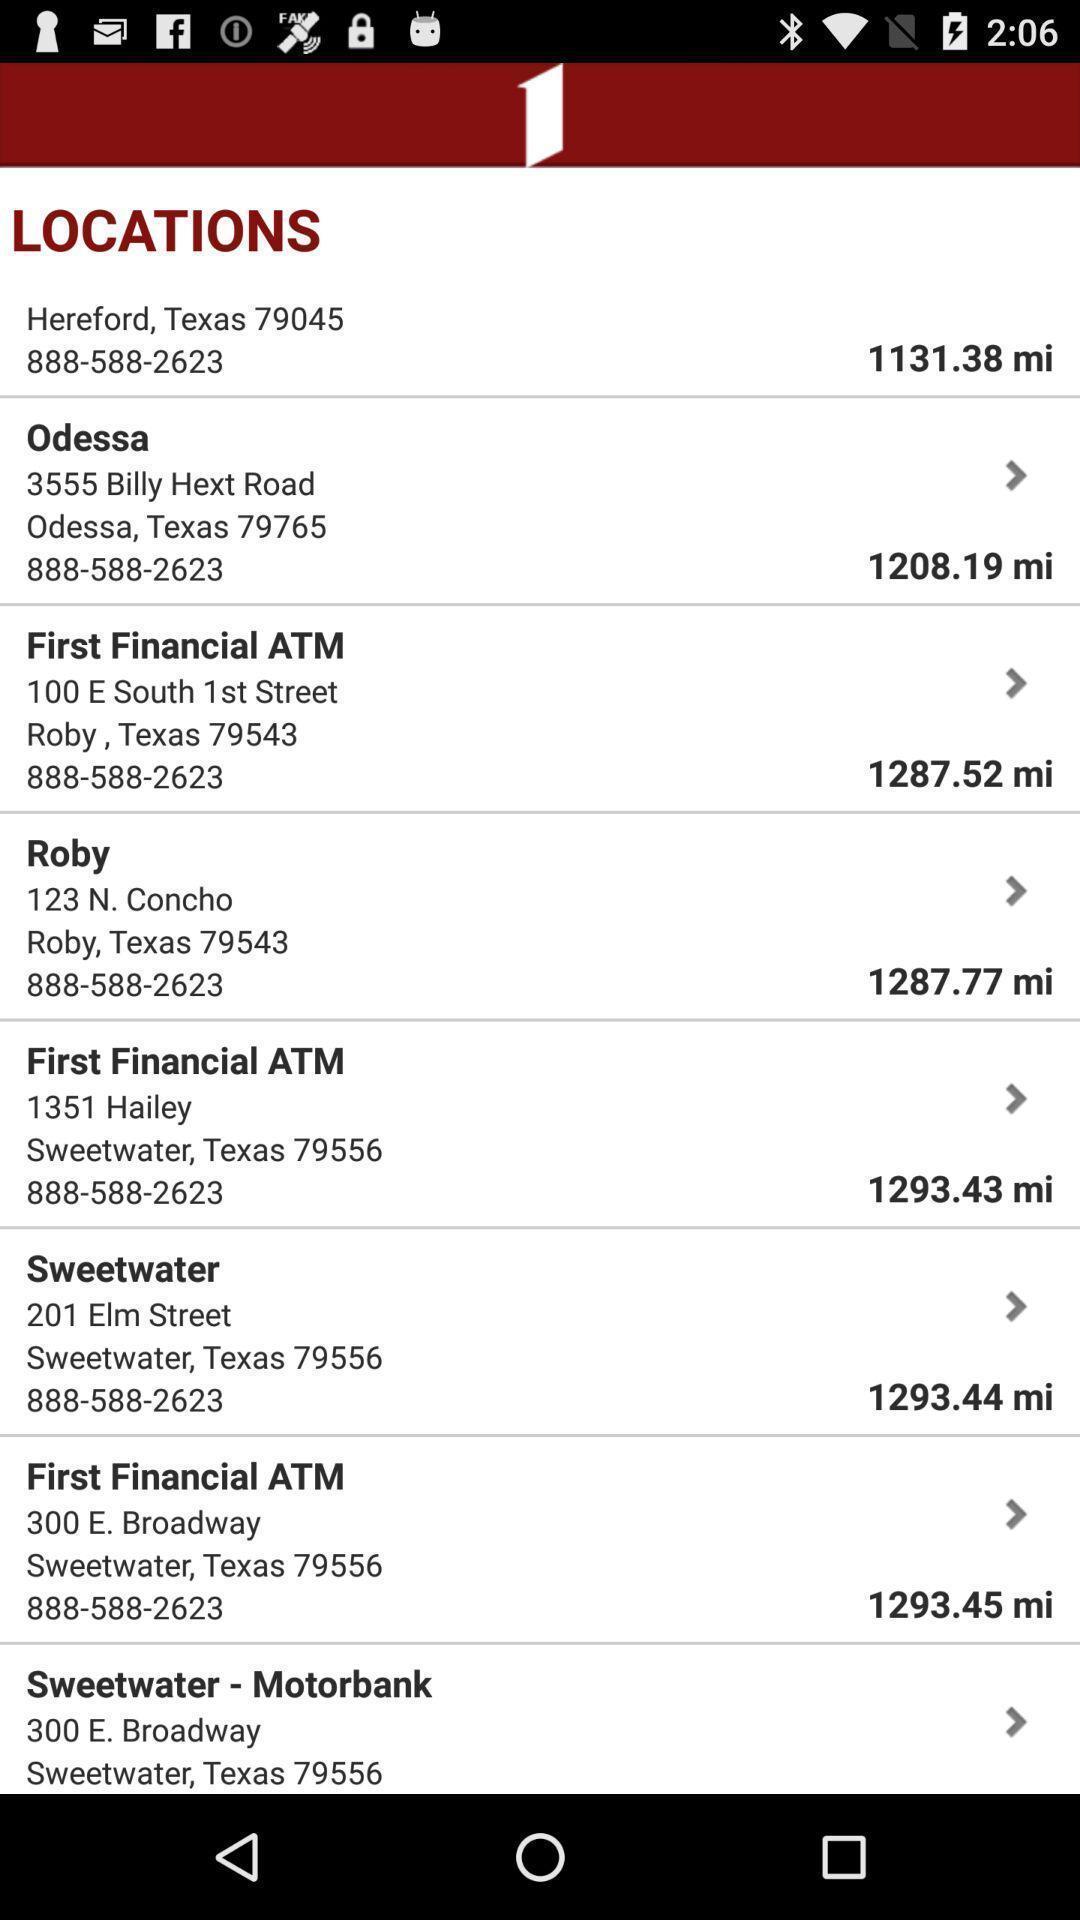Tell me what you see in this picture. Page with details of different locations. 